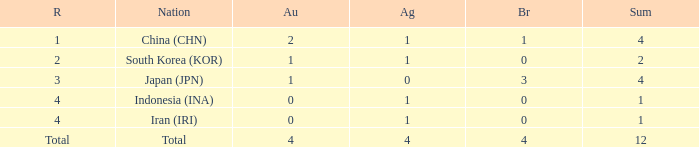What is the fewest gold medals for the nation with 4 silvers and more than 4 bronze? None. 